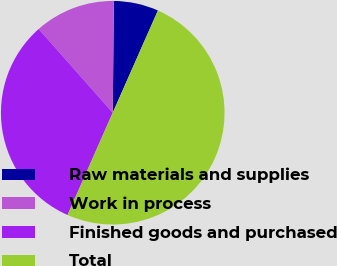Convert chart. <chart><loc_0><loc_0><loc_500><loc_500><pie_chart><fcel>Raw materials and supplies<fcel>Work in process<fcel>Finished goods and purchased<fcel>Total<nl><fcel>6.46%<fcel>11.69%<fcel>31.85%<fcel>50.0%<nl></chart> 